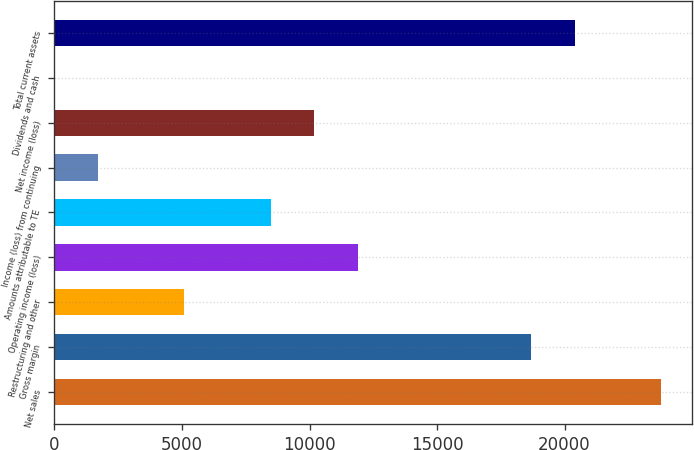Convert chart. <chart><loc_0><loc_0><loc_500><loc_500><bar_chart><fcel>Net sales<fcel>Gross margin<fcel>Restructuring and other<fcel>Operating income (loss)<fcel>Amounts attributable to TE<fcel>Income (loss) from continuing<fcel>Net income (loss)<fcel>Dividends and cash<fcel>Total current assets<nl><fcel>23788.6<fcel>18691.2<fcel>5098.06<fcel>11894.6<fcel>8496.34<fcel>1699.78<fcel>10195.5<fcel>0.64<fcel>20390.3<nl></chart> 